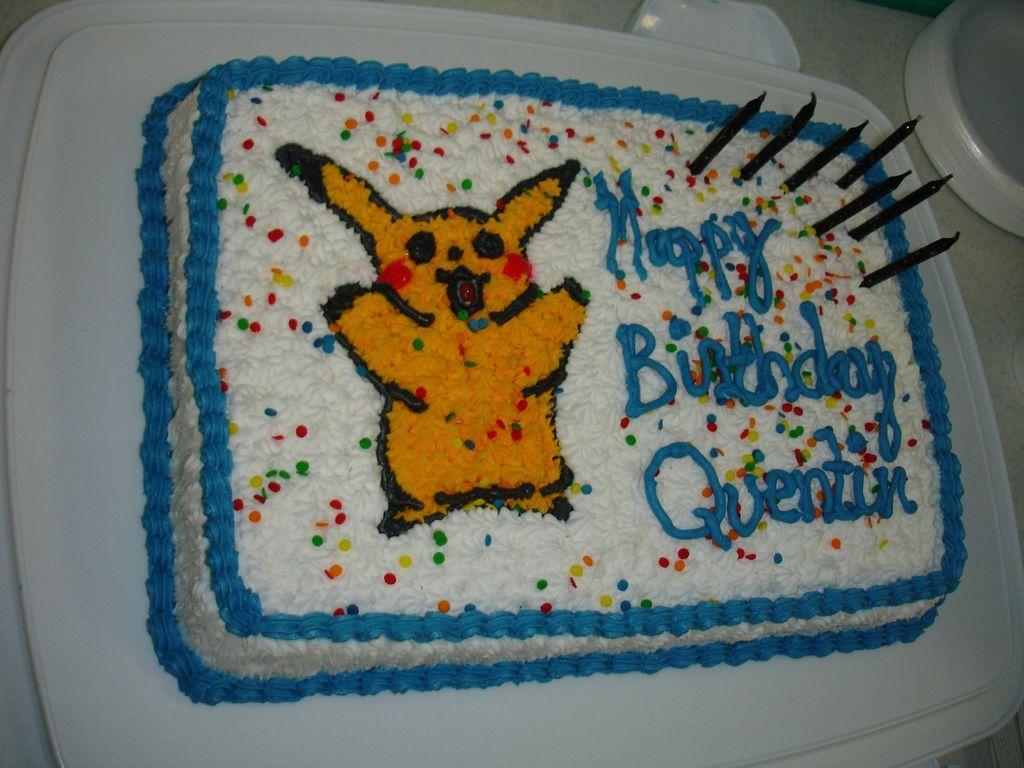How would you summarize this image in a sentence or two? In this image, I can see a cake with candles, which is placed on the table. At the top right side of the image, I can see the plates. 